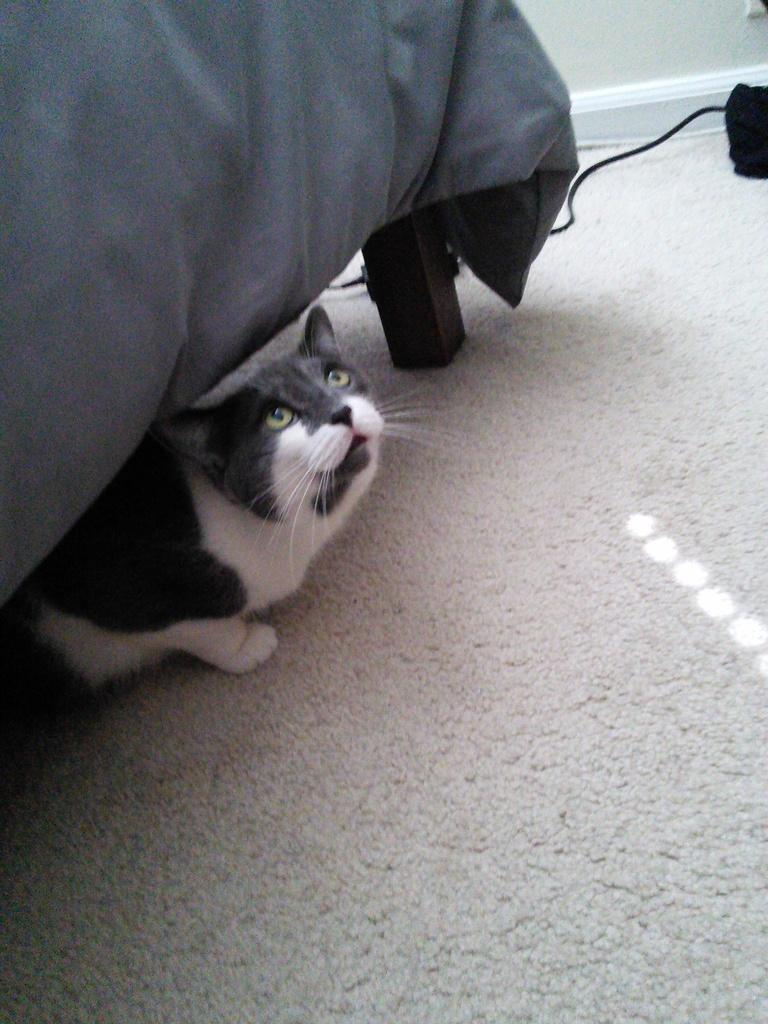Could you give a brief overview of what you see in this image? In this picture there is a cat under the bed. At the back there is an object and there is a wall. At the bottom there is a mat and the bed is covered with grey color cloth. 